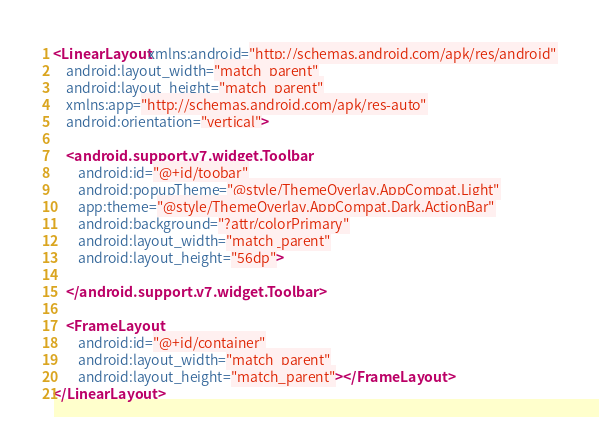Convert code to text. <code><loc_0><loc_0><loc_500><loc_500><_XML_><LinearLayout xmlns:android="http://schemas.android.com/apk/res/android"
    android:layout_width="match_parent"
    android:layout_height="match_parent"
    xmlns:app="http://schemas.android.com/apk/res-auto"
    android:orientation="vertical">

    <android.support.v7.widget.Toolbar
        android:id="@+id/toobar"
        android:popupTheme="@style/ThemeOverlay.AppCompat.Light"
        app:theme="@style/ThemeOverlay.AppCompat.Dark.ActionBar"
        android:background="?attr/colorPrimary"
        android:layout_width="match_parent"
        android:layout_height="56dp">

    </android.support.v7.widget.Toolbar>

    <FrameLayout
        android:id="@+id/container"
        android:layout_width="match_parent"
        android:layout_height="match_parent"></FrameLayout>
</LinearLayout>
</code> 